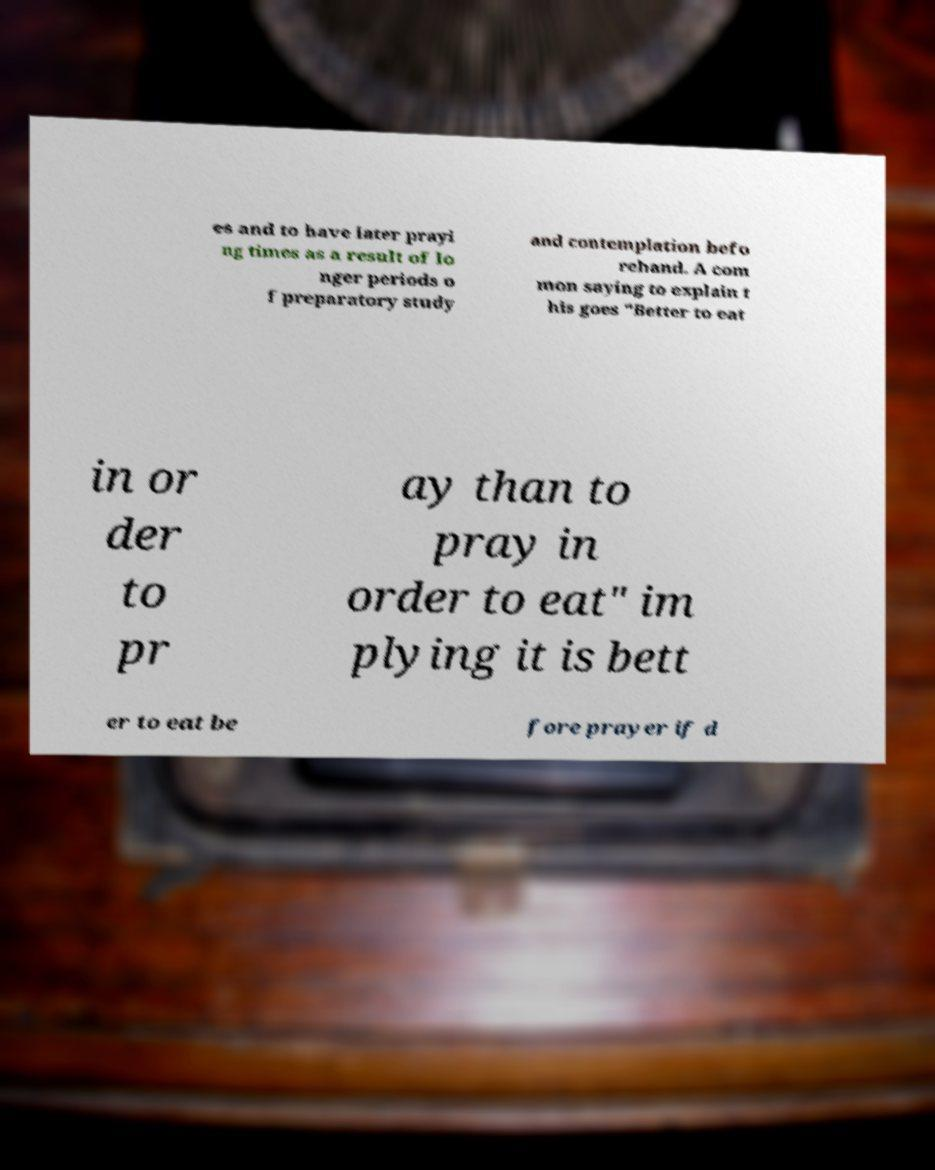I need the written content from this picture converted into text. Can you do that? es and to have later prayi ng times as a result of lo nger periods o f preparatory study and contemplation befo rehand. A com mon saying to explain t his goes "Better to eat in or der to pr ay than to pray in order to eat" im plying it is bett er to eat be fore prayer if d 